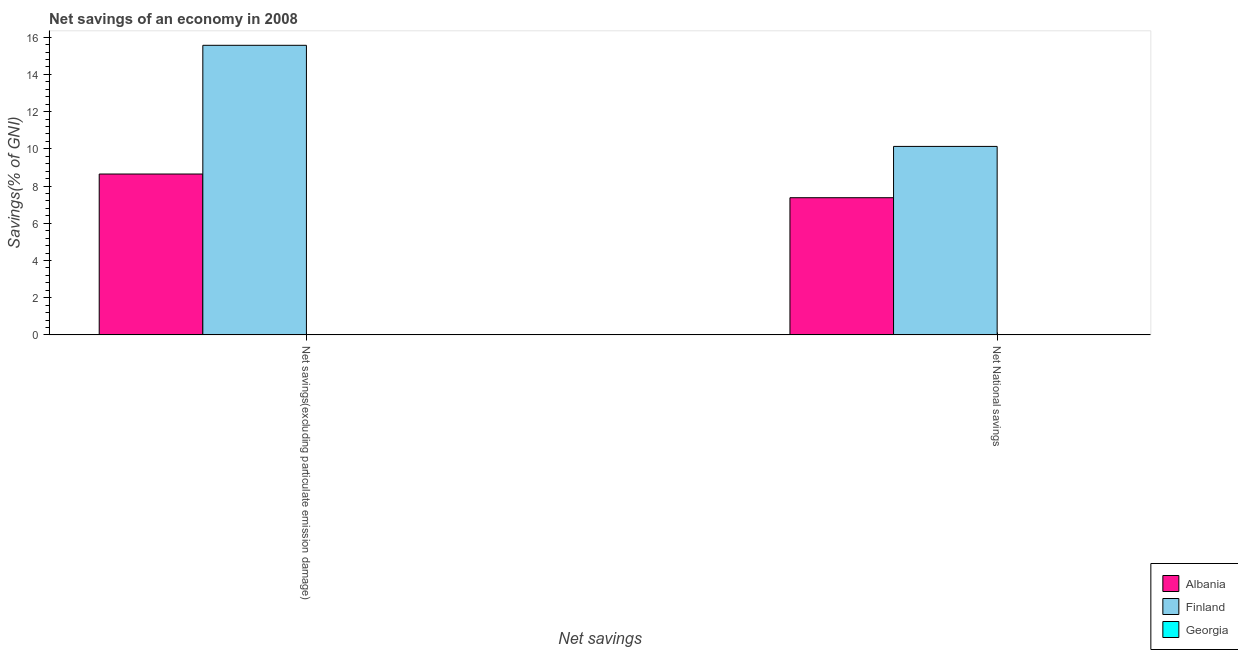How many different coloured bars are there?
Provide a short and direct response. 2. How many groups of bars are there?
Offer a terse response. 2. Are the number of bars on each tick of the X-axis equal?
Keep it short and to the point. Yes. How many bars are there on the 1st tick from the right?
Ensure brevity in your answer.  2. What is the label of the 2nd group of bars from the left?
Offer a terse response. Net National savings. What is the net national savings in Georgia?
Offer a terse response. 0. Across all countries, what is the maximum net savings(excluding particulate emission damage)?
Your response must be concise. 15.56. Across all countries, what is the minimum net national savings?
Ensure brevity in your answer.  0. What is the total net savings(excluding particulate emission damage) in the graph?
Provide a short and direct response. 24.21. What is the difference between the net savings(excluding particulate emission damage) in Finland and that in Albania?
Ensure brevity in your answer.  6.92. What is the difference between the net savings(excluding particulate emission damage) in Georgia and the net national savings in Finland?
Your answer should be compact. -10.13. What is the average net national savings per country?
Provide a succinct answer. 5.83. What is the difference between the net national savings and net savings(excluding particulate emission damage) in Albania?
Keep it short and to the point. -1.27. Is the net savings(excluding particulate emission damage) in Finland less than that in Albania?
Make the answer very short. No. In how many countries, is the net national savings greater than the average net national savings taken over all countries?
Make the answer very short. 2. How many bars are there?
Keep it short and to the point. 4. What is the difference between two consecutive major ticks on the Y-axis?
Offer a terse response. 2. Are the values on the major ticks of Y-axis written in scientific E-notation?
Your response must be concise. No. Does the graph contain grids?
Make the answer very short. No. How are the legend labels stacked?
Your response must be concise. Vertical. What is the title of the graph?
Your answer should be very brief. Net savings of an economy in 2008. What is the label or title of the X-axis?
Provide a succinct answer. Net savings. What is the label or title of the Y-axis?
Give a very brief answer. Savings(% of GNI). What is the Savings(% of GNI) in Albania in Net savings(excluding particulate emission damage)?
Your answer should be very brief. 8.64. What is the Savings(% of GNI) of Finland in Net savings(excluding particulate emission damage)?
Ensure brevity in your answer.  15.56. What is the Savings(% of GNI) of Georgia in Net savings(excluding particulate emission damage)?
Offer a very short reply. 0. What is the Savings(% of GNI) of Albania in Net National savings?
Your answer should be very brief. 7.37. What is the Savings(% of GNI) in Finland in Net National savings?
Your response must be concise. 10.13. Across all Net savings, what is the maximum Savings(% of GNI) of Albania?
Offer a terse response. 8.64. Across all Net savings, what is the maximum Savings(% of GNI) of Finland?
Keep it short and to the point. 15.56. Across all Net savings, what is the minimum Savings(% of GNI) in Albania?
Keep it short and to the point. 7.37. Across all Net savings, what is the minimum Savings(% of GNI) in Finland?
Provide a succinct answer. 10.13. What is the total Savings(% of GNI) in Albania in the graph?
Your response must be concise. 16.02. What is the total Savings(% of GNI) of Finland in the graph?
Provide a succinct answer. 25.69. What is the total Savings(% of GNI) of Georgia in the graph?
Your response must be concise. 0. What is the difference between the Savings(% of GNI) of Albania in Net savings(excluding particulate emission damage) and that in Net National savings?
Your answer should be compact. 1.27. What is the difference between the Savings(% of GNI) of Finland in Net savings(excluding particulate emission damage) and that in Net National savings?
Offer a terse response. 5.43. What is the difference between the Savings(% of GNI) of Albania in Net savings(excluding particulate emission damage) and the Savings(% of GNI) of Finland in Net National savings?
Your answer should be very brief. -1.48. What is the average Savings(% of GNI) of Albania per Net savings?
Your answer should be compact. 8.01. What is the average Savings(% of GNI) in Finland per Net savings?
Your answer should be compact. 12.85. What is the average Savings(% of GNI) in Georgia per Net savings?
Your answer should be compact. 0. What is the difference between the Savings(% of GNI) of Albania and Savings(% of GNI) of Finland in Net savings(excluding particulate emission damage)?
Your response must be concise. -6.92. What is the difference between the Savings(% of GNI) in Albania and Savings(% of GNI) in Finland in Net National savings?
Your answer should be compact. -2.76. What is the ratio of the Savings(% of GNI) in Albania in Net savings(excluding particulate emission damage) to that in Net National savings?
Ensure brevity in your answer.  1.17. What is the ratio of the Savings(% of GNI) of Finland in Net savings(excluding particulate emission damage) to that in Net National savings?
Make the answer very short. 1.54. What is the difference between the highest and the second highest Savings(% of GNI) in Albania?
Offer a very short reply. 1.27. What is the difference between the highest and the second highest Savings(% of GNI) in Finland?
Offer a terse response. 5.43. What is the difference between the highest and the lowest Savings(% of GNI) of Albania?
Make the answer very short. 1.27. What is the difference between the highest and the lowest Savings(% of GNI) in Finland?
Give a very brief answer. 5.43. 